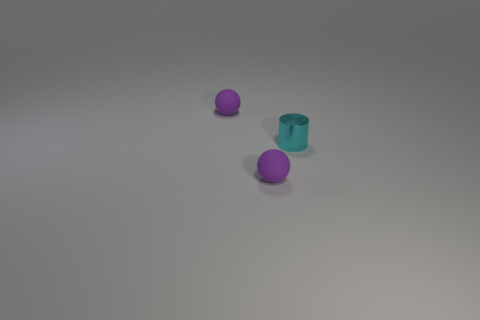How many cylinders are on the right side of the purple matte thing that is behind the small cylinder? Upon observing the image, it appears there is only one cylinder situated on the right side of the purple object that is in the background behind the small cylinder. This single cylinder has a translucent teal color with a matte finish. 